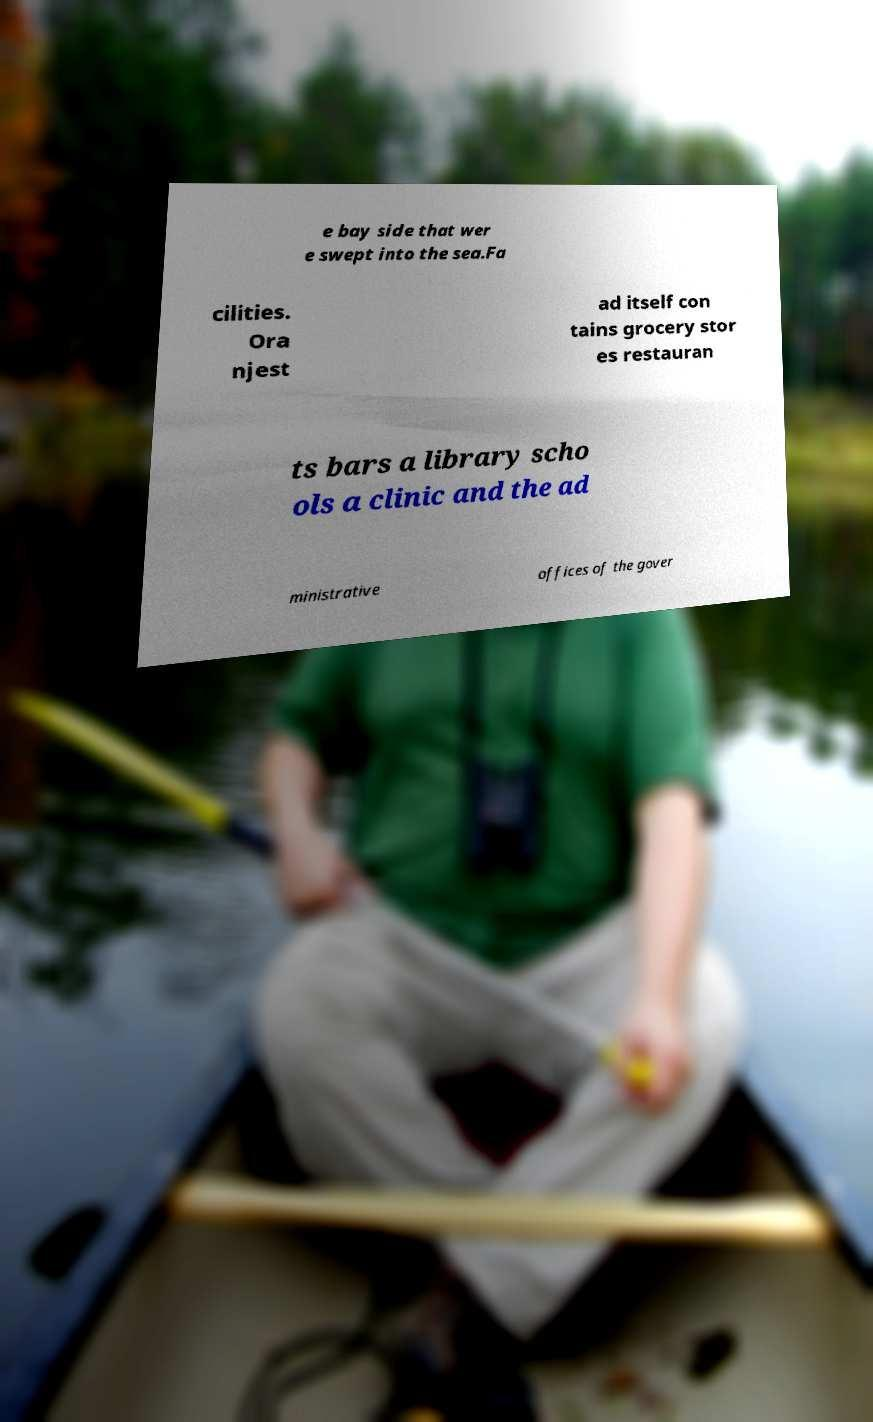Please read and relay the text visible in this image. What does it say? e bay side that wer e swept into the sea.Fa cilities. Ora njest ad itself con tains grocery stor es restauran ts bars a library scho ols a clinic and the ad ministrative offices of the gover 